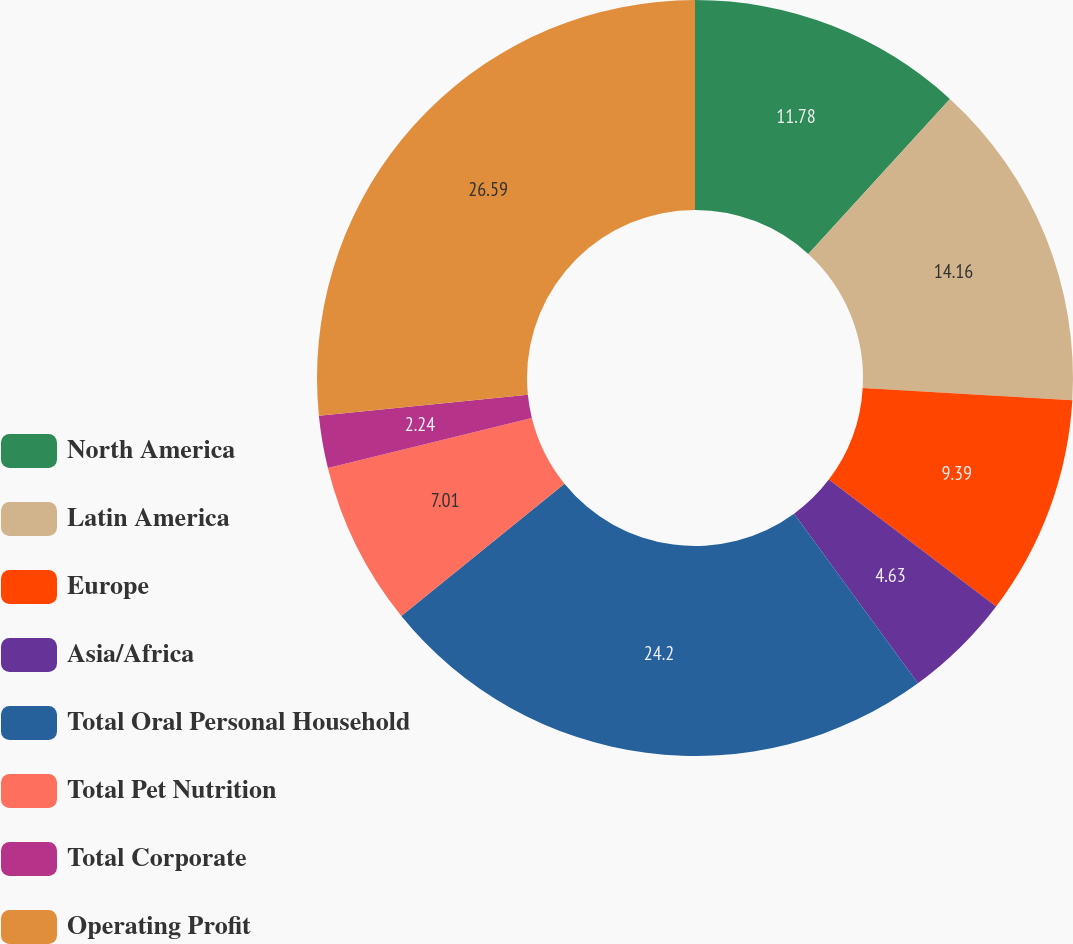Convert chart. <chart><loc_0><loc_0><loc_500><loc_500><pie_chart><fcel>North America<fcel>Latin America<fcel>Europe<fcel>Asia/Africa<fcel>Total Oral Personal Household<fcel>Total Pet Nutrition<fcel>Total Corporate<fcel>Operating Profit<nl><fcel>11.78%<fcel>14.16%<fcel>9.39%<fcel>4.63%<fcel>24.2%<fcel>7.01%<fcel>2.24%<fcel>26.59%<nl></chart> 